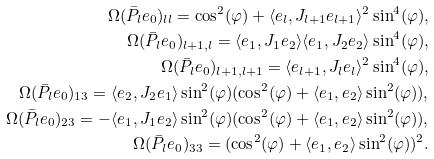Convert formula to latex. <formula><loc_0><loc_0><loc_500><loc_500>\Omega ( \bar { P } _ { l } e _ { 0 } ) _ { l l } = \cos ^ { 2 } ( \varphi ) + \langle e _ { l } , J _ { l + 1 } e _ { l + 1 } \rangle ^ { 2 } \sin ^ { 4 } ( \varphi ) , \\ \Omega ( \bar { P } _ { l } e _ { 0 } ) _ { l + 1 , l } = \langle e _ { 1 } , J _ { 1 } e _ { 2 } \rangle \langle e _ { 1 } , J _ { 2 } e _ { 2 } \rangle \sin ^ { 4 } ( \varphi ) , \\ \Omega ( \bar { P } _ { l } e _ { 0 } ) _ { l + 1 , l + 1 } = \langle e _ { l + 1 } , J _ { l } e _ { l } \rangle ^ { 2 } \sin ^ { 4 } ( \varphi ) , \\ \Omega ( \bar { P } _ { l } e _ { 0 } ) _ { 1 3 } = \langle e _ { 2 } , J _ { 2 } e _ { 1 } \rangle \sin ^ { 2 } ( \varphi ) ( \cos ^ { 2 } ( \varphi ) + \langle e _ { 1 } , e _ { 2 } \rangle \sin ^ { 2 } ( \varphi ) ) , \\ \Omega ( \bar { P } _ { l } e _ { 0 } ) _ { 2 3 } = - \langle e _ { 1 } , J _ { 1 } e _ { 2 } \rangle \sin ^ { 2 } ( \varphi ) ( \cos ^ { 2 } ( \varphi ) + \langle e _ { 1 } , e _ { 2 } \rangle \sin ^ { 2 } ( \varphi ) ) , \\ \Omega ( \bar { P } _ { l } e _ { 0 } ) _ { 3 3 } = ( \cos ^ { 2 } ( \varphi ) + \langle e _ { 1 } , e _ { 2 } \rangle \sin ^ { 2 } ( \varphi ) ) ^ { 2 } .</formula> 